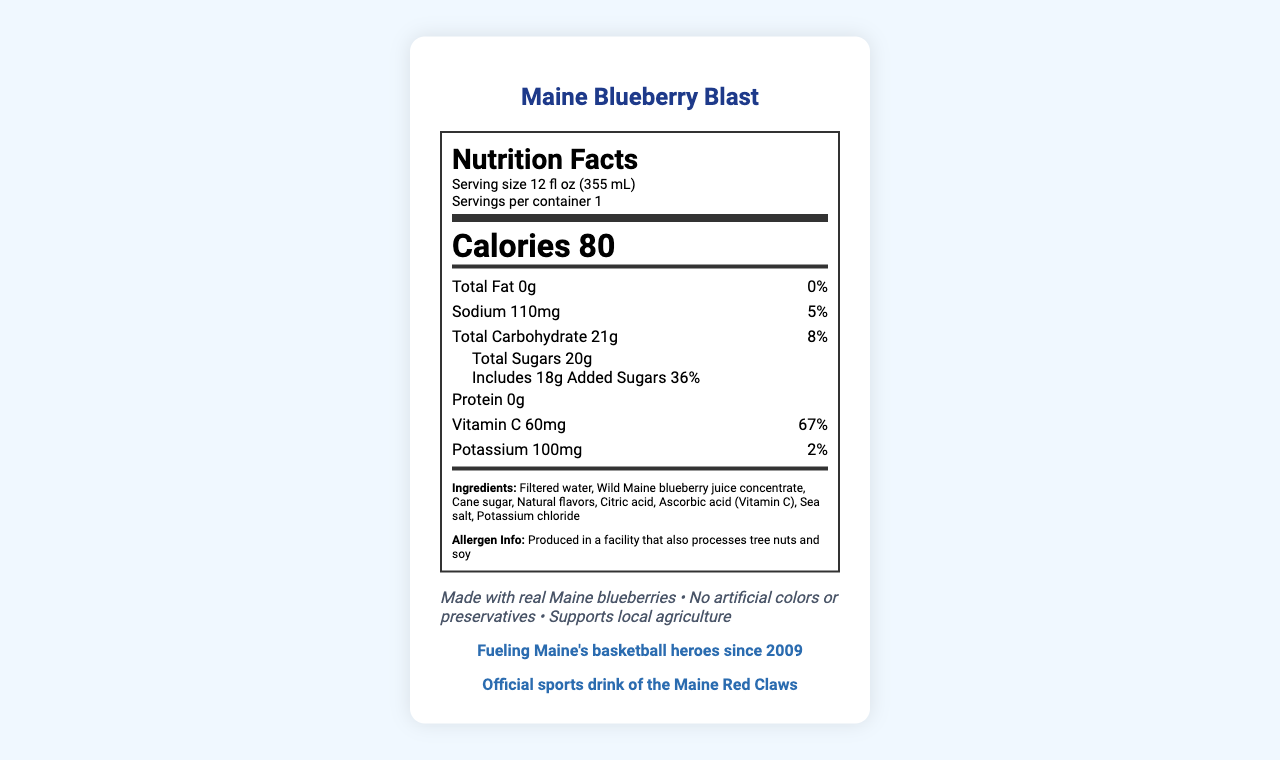how many calories are in a single serving of Maine Blueberry Blast? The nutrition label states that there are 80 calories in one serving of Maine Blueberry Blast.
Answer: 80 what is the serving size of Maine Blueberry Blast? The serving size is listed as 12 fl oz (355 mL) on the nutrition label.
Answer: 12 fl oz (355 mL) how much total fat does Maine Blueberry Blast contain per serving? The nutrition label shows that the total fat per serving is 0g, which is 0% of the daily value.
Answer: 0g what is the amount of added sugars in the drink? The label indicates that there are 18g of added sugars in the drink, which accounts for 36% of the daily value.
Answer: 18g what are the main ingredients of the drink? The ingredients are explicitly listed on the label: Filtered water, Wild Maine blueberry juice concentrate, Cane sugar, Natural flavors, Citric acid, Ascorbic acid (Vitamin C), Sea salt, Potassium chloride.
Answer: Filtered water, Wild Maine blueberry juice concentrate, Cane sugar, Natural flavors, Citric acid, Ascorbic acid (Vitamin C), Sea salt, Potassium chloride what is the percentage of daily value for Vitamin C in Maine Blueberry Blast? The nutrition facts show that one serving provides 67% of the daily value for Vitamin C.
Answer: 67% what allergen information is provided about Maine Blueberry Blast? A. Contains peanuts B. Contains dairy C. Produced in a facility that also processes tree nuts and soy The allergen information listed states that it is produced in a facility that also processes tree nuts and soy.
Answer: C. Produced in a facility that also processes tree nuts and soy how much sodium is in a serving of Maine Blueberry Blast? A. 70mg B. 110mg C. 150mg The nutrition facts list 110mg of sodium per serving, which is 5% of the daily value.
Answer: B. 110mg Does Maine Blueberry Blast contain artificial colors or preservatives? One of the claim statements on the label states "No artificial colors or preservatives".
Answer: No Is Maine Blueberry Blast branded as the official sports drink of the Maine Red Claws? The label contains a section stating "Official sports drink of the Maine Red Claws".
Answer: Yes Summarize the main idea of the Maine Blueberry Blast nutrition label. The nutrition label for Maine Blueberry Blast outlines the drink's nutritional content, ingredient list, and several claim statements, emphasizing its natural ingredients and local production, as well as its endorsement by the Maine Red Claws.
Answer: Maine Blueberry Blast is a sports drink endorsed by the Maine Red Claws. It contains 80 calories per 12 fl oz serving, with 21g of carbohydrates, 20g of total sugars (including 18g added sugars), 110mg of sodium, and is notably high in Vitamin C. The drink is made from natural ingredients without artificial colors or preservatives and supports local agriculture, but it is produced in a facility that also processes tree nuts and soy. Can kids drink this beverage? The document does not provide any information regarding whether the beverage is suitable for children. There are no age guidelines or restrictions mentioned.
Answer: Cannot be determined 